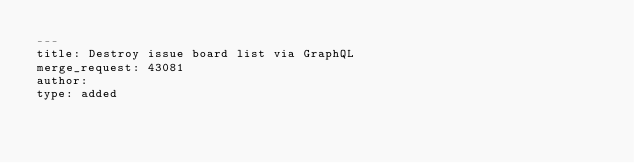Convert code to text. <code><loc_0><loc_0><loc_500><loc_500><_YAML_>---
title: Destroy issue board list via GraphQL
merge_request: 43081
author:
type: added
</code> 